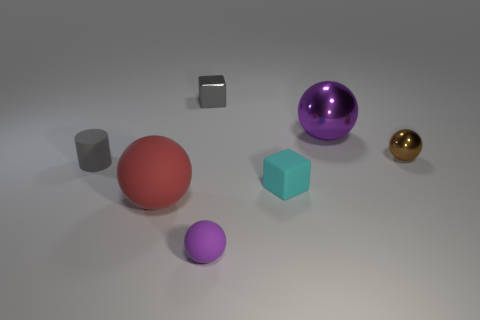What number of other objects are there of the same color as the small matte sphere?
Offer a very short reply. 1. How many purple objects are small objects or large shiny balls?
Provide a short and direct response. 2. There is a large object to the right of the large rubber sphere; does it have the same shape as the tiny matte object that is on the left side of the big matte ball?
Ensure brevity in your answer.  No. How many other things are there of the same material as the brown object?
Give a very brief answer. 2. Is there a ball behind the big object behind the small gray thing on the left side of the big red matte ball?
Give a very brief answer. No. Do the cyan block and the cylinder have the same material?
Offer a very short reply. Yes. Are there any other things that are the same shape as the cyan object?
Your answer should be compact. Yes. What material is the large thing right of the metallic thing that is to the left of the small purple thing?
Give a very brief answer. Metal. How big is the block that is behind the small cyan block?
Make the answer very short. Small. What color is the small matte thing that is both on the left side of the tiny cyan cube and behind the red matte thing?
Offer a terse response. Gray. 